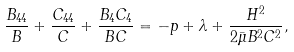<formula> <loc_0><loc_0><loc_500><loc_500>\frac { B _ { 4 4 } } { B } + \frac { C _ { 4 4 } } { C } + \frac { B _ { 4 } C _ { 4 } } { B C } = - p + \lambda + \frac { H ^ { 2 } } { 2 \bar { \mu } B ^ { 2 } C ^ { 2 } } ,</formula> 